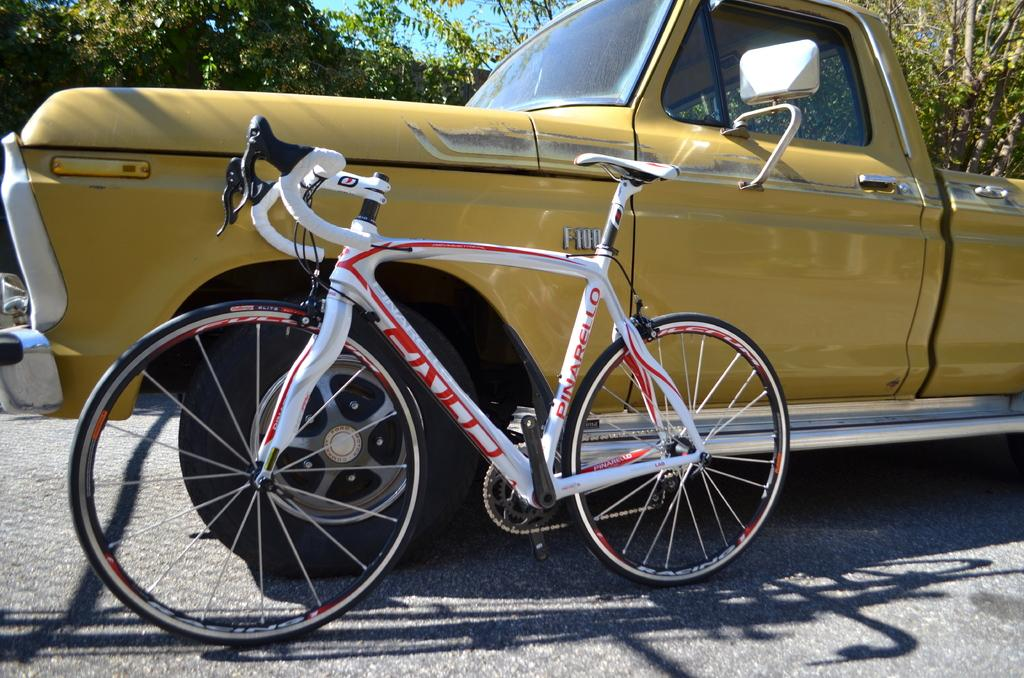What type of vehicle is present in the image? There is a car in the image. What other mode of transportation can be seen in the image? There is a bicycle in the image. Where are the car and bicycle located in the image? Both the car and the bicycle are placed on the road. What natural elements are visible in the image? Trees and the sky are visible in the image. How does the car kick the linen in the image? There is no car kicking any linen in the image; the car and bicycle are placed on the road, and there is no mention of linen. 